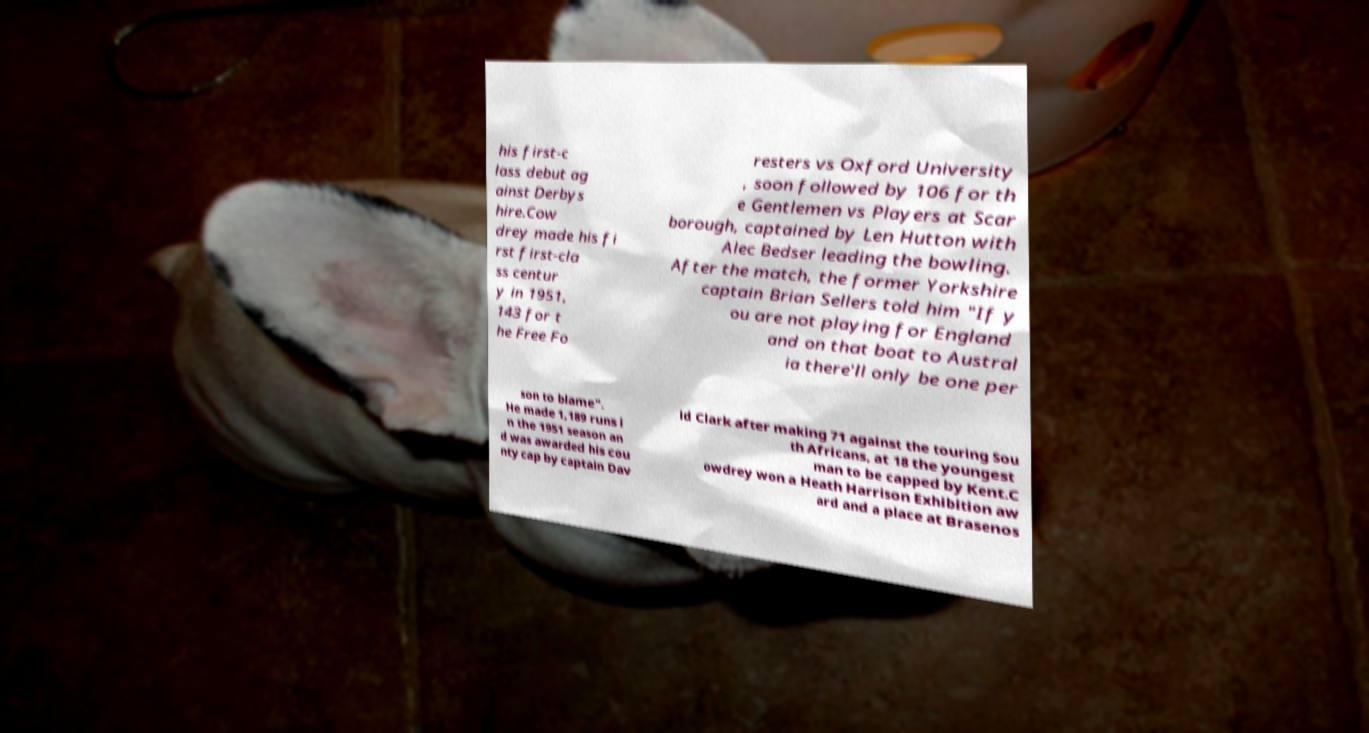Please identify and transcribe the text found in this image. his first-c lass debut ag ainst Derbys hire.Cow drey made his fi rst first-cla ss centur y in 1951, 143 for t he Free Fo resters vs Oxford University , soon followed by 106 for th e Gentlemen vs Players at Scar borough, captained by Len Hutton with Alec Bedser leading the bowling. After the match, the former Yorkshire captain Brian Sellers told him "If y ou are not playing for England and on that boat to Austral ia there'll only be one per son to blame". He made 1,189 runs i n the 1951 season an d was awarded his cou nty cap by captain Dav id Clark after making 71 against the touring Sou th Africans, at 18 the youngest man to be capped by Kent.C owdrey won a Heath Harrison Exhibition aw ard and a place at Brasenos 